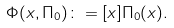<formula> <loc_0><loc_0><loc_500><loc_500>\Phi ( x , \Pi _ { 0 } ) \colon = [ x ] \Pi _ { 0 } ( x ) .</formula> 